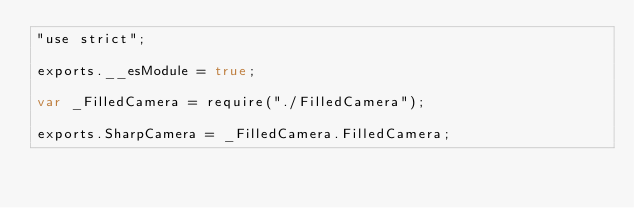Convert code to text. <code><loc_0><loc_0><loc_500><loc_500><_JavaScript_>"use strict";

exports.__esModule = true;

var _FilledCamera = require("./FilledCamera");

exports.SharpCamera = _FilledCamera.FilledCamera;</code> 